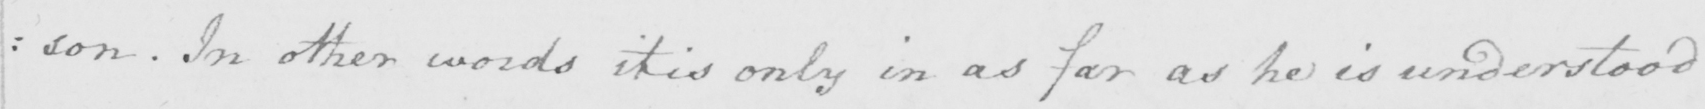Transcribe the text shown in this historical manuscript line. : son . In other words it is only in as far as he is understood 